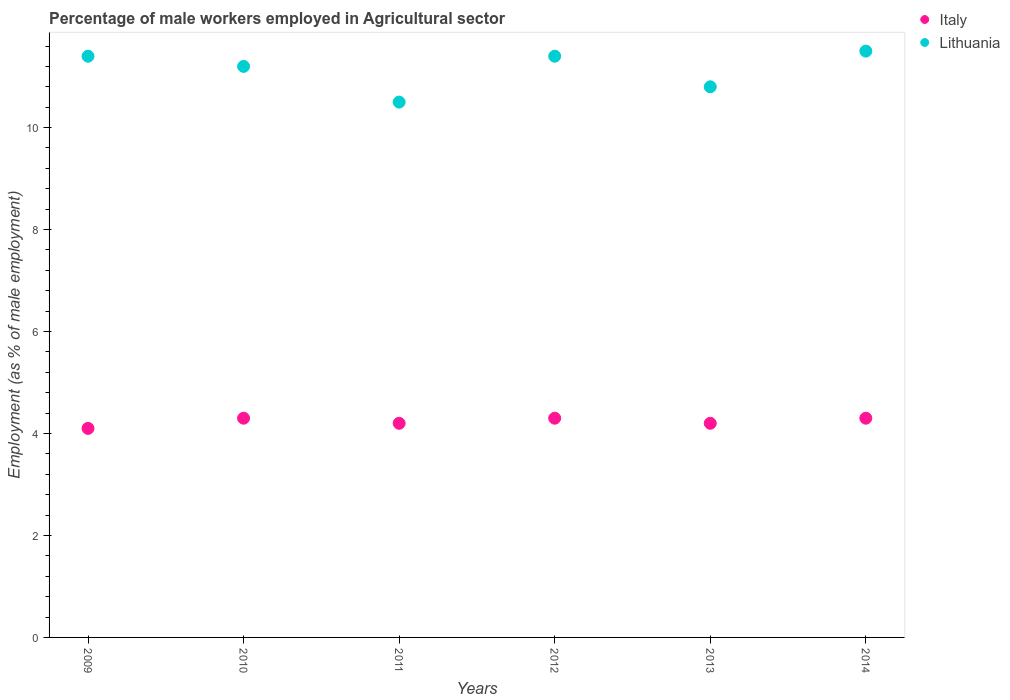How many different coloured dotlines are there?
Give a very brief answer. 2. What is the percentage of male workers employed in Agricultural sector in Italy in 2014?
Provide a short and direct response. 4.3. Across all years, what is the maximum percentage of male workers employed in Agricultural sector in Lithuania?
Your response must be concise. 11.5. Across all years, what is the minimum percentage of male workers employed in Agricultural sector in Italy?
Ensure brevity in your answer.  4.1. In which year was the percentage of male workers employed in Agricultural sector in Italy maximum?
Offer a terse response. 2010. In which year was the percentage of male workers employed in Agricultural sector in Lithuania minimum?
Provide a succinct answer. 2011. What is the total percentage of male workers employed in Agricultural sector in Italy in the graph?
Your answer should be very brief. 25.4. What is the difference between the percentage of male workers employed in Agricultural sector in Italy in 2011 and that in 2014?
Make the answer very short. -0.1. What is the difference between the percentage of male workers employed in Agricultural sector in Lithuania in 2011 and the percentage of male workers employed in Agricultural sector in Italy in 2009?
Make the answer very short. 6.4. What is the average percentage of male workers employed in Agricultural sector in Lithuania per year?
Make the answer very short. 11.13. In the year 2011, what is the difference between the percentage of male workers employed in Agricultural sector in Italy and percentage of male workers employed in Agricultural sector in Lithuania?
Offer a terse response. -6.3. What is the ratio of the percentage of male workers employed in Agricultural sector in Lithuania in 2013 to that in 2014?
Make the answer very short. 0.94. What is the difference between the highest and the second highest percentage of male workers employed in Agricultural sector in Italy?
Keep it short and to the point. 0. What is the difference between the highest and the lowest percentage of male workers employed in Agricultural sector in Italy?
Provide a short and direct response. 0.2. In how many years, is the percentage of male workers employed in Agricultural sector in Lithuania greater than the average percentage of male workers employed in Agricultural sector in Lithuania taken over all years?
Provide a short and direct response. 4. Does the percentage of male workers employed in Agricultural sector in Italy monotonically increase over the years?
Provide a succinct answer. No. Is the percentage of male workers employed in Agricultural sector in Italy strictly less than the percentage of male workers employed in Agricultural sector in Lithuania over the years?
Offer a very short reply. Yes. What is the difference between two consecutive major ticks on the Y-axis?
Your answer should be compact. 2. Are the values on the major ticks of Y-axis written in scientific E-notation?
Give a very brief answer. No. Does the graph contain grids?
Provide a succinct answer. No. Where does the legend appear in the graph?
Keep it short and to the point. Top right. What is the title of the graph?
Make the answer very short. Percentage of male workers employed in Agricultural sector. Does "Sweden" appear as one of the legend labels in the graph?
Your response must be concise. No. What is the label or title of the X-axis?
Your answer should be compact. Years. What is the label or title of the Y-axis?
Your response must be concise. Employment (as % of male employment). What is the Employment (as % of male employment) in Italy in 2009?
Your response must be concise. 4.1. What is the Employment (as % of male employment) of Lithuania in 2009?
Make the answer very short. 11.4. What is the Employment (as % of male employment) in Italy in 2010?
Make the answer very short. 4.3. What is the Employment (as % of male employment) in Lithuania in 2010?
Provide a short and direct response. 11.2. What is the Employment (as % of male employment) of Italy in 2011?
Give a very brief answer. 4.2. What is the Employment (as % of male employment) of Italy in 2012?
Provide a succinct answer. 4.3. What is the Employment (as % of male employment) in Lithuania in 2012?
Provide a short and direct response. 11.4. What is the Employment (as % of male employment) in Italy in 2013?
Your response must be concise. 4.2. What is the Employment (as % of male employment) of Lithuania in 2013?
Offer a very short reply. 10.8. What is the Employment (as % of male employment) of Italy in 2014?
Your answer should be very brief. 4.3. What is the Employment (as % of male employment) of Lithuania in 2014?
Your answer should be very brief. 11.5. Across all years, what is the maximum Employment (as % of male employment) in Italy?
Your answer should be very brief. 4.3. Across all years, what is the minimum Employment (as % of male employment) in Italy?
Offer a very short reply. 4.1. What is the total Employment (as % of male employment) in Italy in the graph?
Your answer should be compact. 25.4. What is the total Employment (as % of male employment) in Lithuania in the graph?
Offer a very short reply. 66.8. What is the difference between the Employment (as % of male employment) in Italy in 2009 and that in 2012?
Your answer should be compact. -0.2. What is the difference between the Employment (as % of male employment) in Lithuania in 2009 and that in 2012?
Give a very brief answer. 0. What is the difference between the Employment (as % of male employment) of Italy in 2009 and that in 2013?
Provide a succinct answer. -0.1. What is the difference between the Employment (as % of male employment) in Lithuania in 2009 and that in 2013?
Your answer should be compact. 0.6. What is the difference between the Employment (as % of male employment) in Italy in 2009 and that in 2014?
Make the answer very short. -0.2. What is the difference between the Employment (as % of male employment) in Lithuania in 2009 and that in 2014?
Your answer should be compact. -0.1. What is the difference between the Employment (as % of male employment) of Lithuania in 2010 and that in 2011?
Give a very brief answer. 0.7. What is the difference between the Employment (as % of male employment) of Italy in 2010 and that in 2012?
Ensure brevity in your answer.  0. What is the difference between the Employment (as % of male employment) in Lithuania in 2010 and that in 2012?
Provide a succinct answer. -0.2. What is the difference between the Employment (as % of male employment) in Italy in 2010 and that in 2013?
Give a very brief answer. 0.1. What is the difference between the Employment (as % of male employment) of Italy in 2011 and that in 2012?
Your answer should be very brief. -0.1. What is the difference between the Employment (as % of male employment) in Lithuania in 2011 and that in 2013?
Give a very brief answer. -0.3. What is the difference between the Employment (as % of male employment) in Italy in 2011 and that in 2014?
Provide a short and direct response. -0.1. What is the difference between the Employment (as % of male employment) in Lithuania in 2011 and that in 2014?
Give a very brief answer. -1. What is the difference between the Employment (as % of male employment) of Italy in 2012 and that in 2013?
Offer a terse response. 0.1. What is the difference between the Employment (as % of male employment) in Lithuania in 2012 and that in 2013?
Your response must be concise. 0.6. What is the difference between the Employment (as % of male employment) of Lithuania in 2012 and that in 2014?
Make the answer very short. -0.1. What is the difference between the Employment (as % of male employment) in Italy in 2013 and that in 2014?
Provide a succinct answer. -0.1. What is the difference between the Employment (as % of male employment) in Lithuania in 2013 and that in 2014?
Ensure brevity in your answer.  -0.7. What is the difference between the Employment (as % of male employment) of Italy in 2009 and the Employment (as % of male employment) of Lithuania in 2010?
Provide a short and direct response. -7.1. What is the difference between the Employment (as % of male employment) in Italy in 2009 and the Employment (as % of male employment) in Lithuania in 2012?
Your answer should be very brief. -7.3. What is the difference between the Employment (as % of male employment) of Italy in 2009 and the Employment (as % of male employment) of Lithuania in 2013?
Provide a succinct answer. -6.7. What is the difference between the Employment (as % of male employment) in Italy in 2010 and the Employment (as % of male employment) in Lithuania in 2012?
Give a very brief answer. -7.1. What is the difference between the Employment (as % of male employment) in Italy in 2010 and the Employment (as % of male employment) in Lithuania in 2014?
Your response must be concise. -7.2. What is the difference between the Employment (as % of male employment) in Italy in 2011 and the Employment (as % of male employment) in Lithuania in 2012?
Ensure brevity in your answer.  -7.2. What is the difference between the Employment (as % of male employment) of Italy in 2011 and the Employment (as % of male employment) of Lithuania in 2013?
Make the answer very short. -6.6. What is the difference between the Employment (as % of male employment) in Italy in 2012 and the Employment (as % of male employment) in Lithuania in 2014?
Make the answer very short. -7.2. What is the average Employment (as % of male employment) in Italy per year?
Provide a short and direct response. 4.23. What is the average Employment (as % of male employment) of Lithuania per year?
Offer a very short reply. 11.13. In the year 2010, what is the difference between the Employment (as % of male employment) in Italy and Employment (as % of male employment) in Lithuania?
Keep it short and to the point. -6.9. In the year 2011, what is the difference between the Employment (as % of male employment) in Italy and Employment (as % of male employment) in Lithuania?
Your response must be concise. -6.3. In the year 2013, what is the difference between the Employment (as % of male employment) in Italy and Employment (as % of male employment) in Lithuania?
Give a very brief answer. -6.6. What is the ratio of the Employment (as % of male employment) in Italy in 2009 to that in 2010?
Make the answer very short. 0.95. What is the ratio of the Employment (as % of male employment) of Lithuania in 2009 to that in 2010?
Your answer should be compact. 1.02. What is the ratio of the Employment (as % of male employment) in Italy in 2009 to that in 2011?
Offer a terse response. 0.98. What is the ratio of the Employment (as % of male employment) of Lithuania in 2009 to that in 2011?
Make the answer very short. 1.09. What is the ratio of the Employment (as % of male employment) in Italy in 2009 to that in 2012?
Your response must be concise. 0.95. What is the ratio of the Employment (as % of male employment) in Lithuania in 2009 to that in 2012?
Make the answer very short. 1. What is the ratio of the Employment (as % of male employment) of Italy in 2009 to that in 2013?
Ensure brevity in your answer.  0.98. What is the ratio of the Employment (as % of male employment) in Lithuania in 2009 to that in 2013?
Ensure brevity in your answer.  1.06. What is the ratio of the Employment (as % of male employment) of Italy in 2009 to that in 2014?
Give a very brief answer. 0.95. What is the ratio of the Employment (as % of male employment) of Lithuania in 2009 to that in 2014?
Offer a very short reply. 0.99. What is the ratio of the Employment (as % of male employment) in Italy in 2010 to that in 2011?
Offer a terse response. 1.02. What is the ratio of the Employment (as % of male employment) in Lithuania in 2010 to that in 2011?
Provide a succinct answer. 1.07. What is the ratio of the Employment (as % of male employment) of Lithuania in 2010 to that in 2012?
Provide a succinct answer. 0.98. What is the ratio of the Employment (as % of male employment) in Italy in 2010 to that in 2013?
Keep it short and to the point. 1.02. What is the ratio of the Employment (as % of male employment) in Lithuania in 2010 to that in 2013?
Your response must be concise. 1.04. What is the ratio of the Employment (as % of male employment) of Italy in 2010 to that in 2014?
Keep it short and to the point. 1. What is the ratio of the Employment (as % of male employment) in Lithuania in 2010 to that in 2014?
Give a very brief answer. 0.97. What is the ratio of the Employment (as % of male employment) in Italy in 2011 to that in 2012?
Your answer should be compact. 0.98. What is the ratio of the Employment (as % of male employment) in Lithuania in 2011 to that in 2012?
Provide a succinct answer. 0.92. What is the ratio of the Employment (as % of male employment) in Lithuania in 2011 to that in 2013?
Make the answer very short. 0.97. What is the ratio of the Employment (as % of male employment) in Italy in 2011 to that in 2014?
Offer a terse response. 0.98. What is the ratio of the Employment (as % of male employment) in Lithuania in 2011 to that in 2014?
Offer a terse response. 0.91. What is the ratio of the Employment (as % of male employment) of Italy in 2012 to that in 2013?
Give a very brief answer. 1.02. What is the ratio of the Employment (as % of male employment) of Lithuania in 2012 to that in 2013?
Your answer should be compact. 1.06. What is the ratio of the Employment (as % of male employment) in Italy in 2013 to that in 2014?
Keep it short and to the point. 0.98. What is the ratio of the Employment (as % of male employment) in Lithuania in 2013 to that in 2014?
Keep it short and to the point. 0.94. What is the difference between the highest and the second highest Employment (as % of male employment) of Lithuania?
Keep it short and to the point. 0.1. What is the difference between the highest and the lowest Employment (as % of male employment) of Italy?
Offer a terse response. 0.2. 